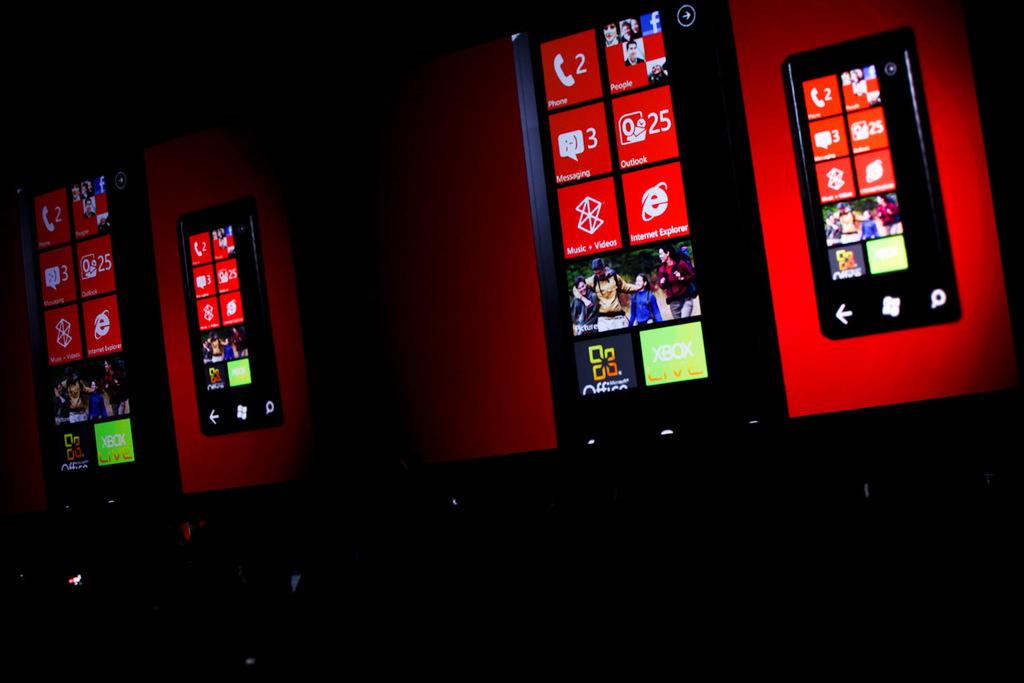What is written on one of the phone icons shown?
Make the answer very short. Internet explorer. What number is in the messaging box?
Keep it short and to the point. 3. 